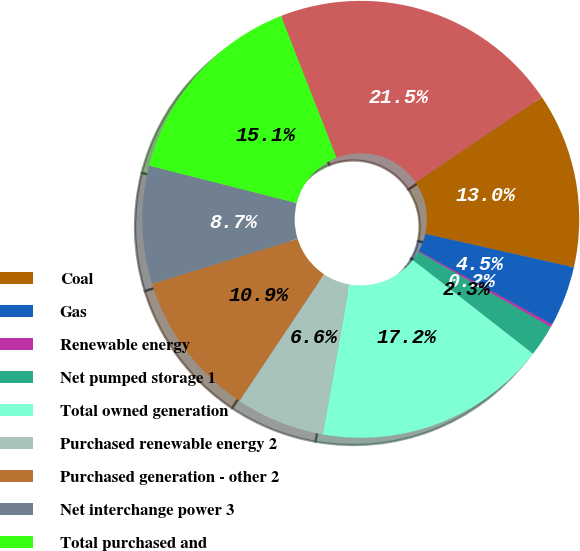Convert chart. <chart><loc_0><loc_0><loc_500><loc_500><pie_chart><fcel>Coal<fcel>Gas<fcel>Renewable energy<fcel>Net pumped storage 1<fcel>Total owned generation<fcel>Purchased renewable energy 2<fcel>Purchased generation - other 2<fcel>Net interchange power 3<fcel>Total purchased and<fcel>Total supply<nl><fcel>12.98%<fcel>4.47%<fcel>0.21%<fcel>2.34%<fcel>17.23%<fcel>6.6%<fcel>10.85%<fcel>8.72%<fcel>15.11%<fcel>21.49%<nl></chart> 